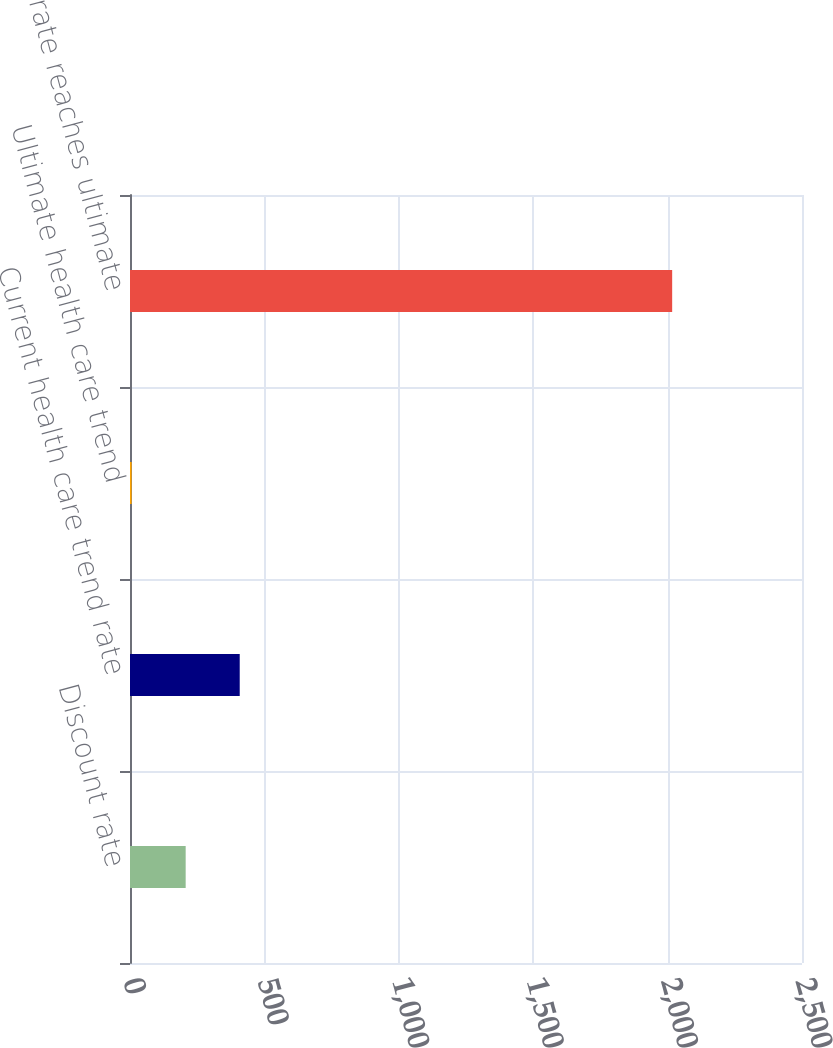Convert chart to OTSL. <chart><loc_0><loc_0><loc_500><loc_500><bar_chart><fcel>Discount rate<fcel>Current health care trend rate<fcel>Ultimate health care trend<fcel>Year rate reaches ultimate<nl><fcel>207.1<fcel>408.2<fcel>6<fcel>2017<nl></chart> 